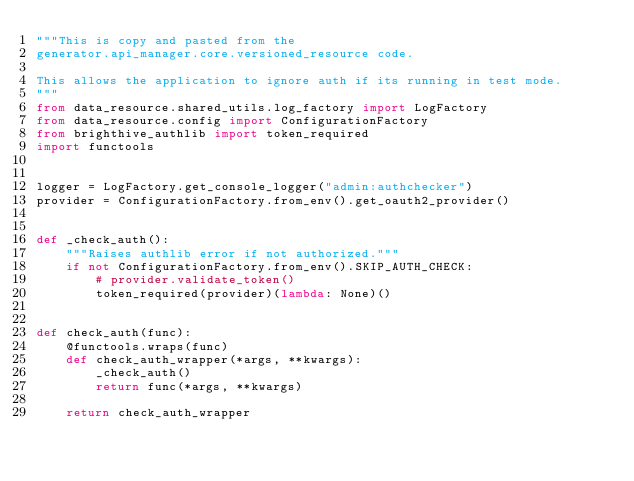<code> <loc_0><loc_0><loc_500><loc_500><_Python_>"""This is copy and pasted from the
generator.api_manager.core.versioned_resource code.

This allows the application to ignore auth if its running in test mode.
"""
from data_resource.shared_utils.log_factory import LogFactory
from data_resource.config import ConfigurationFactory
from brighthive_authlib import token_required
import functools


logger = LogFactory.get_console_logger("admin:authchecker")
provider = ConfigurationFactory.from_env().get_oauth2_provider()


def _check_auth():
    """Raises authlib error if not authorized."""
    if not ConfigurationFactory.from_env().SKIP_AUTH_CHECK:
        # provider.validate_token()
        token_required(provider)(lambda: None)()


def check_auth(func):
    @functools.wraps(func)
    def check_auth_wrapper(*args, **kwargs):
        _check_auth()
        return func(*args, **kwargs)

    return check_auth_wrapper
</code> 